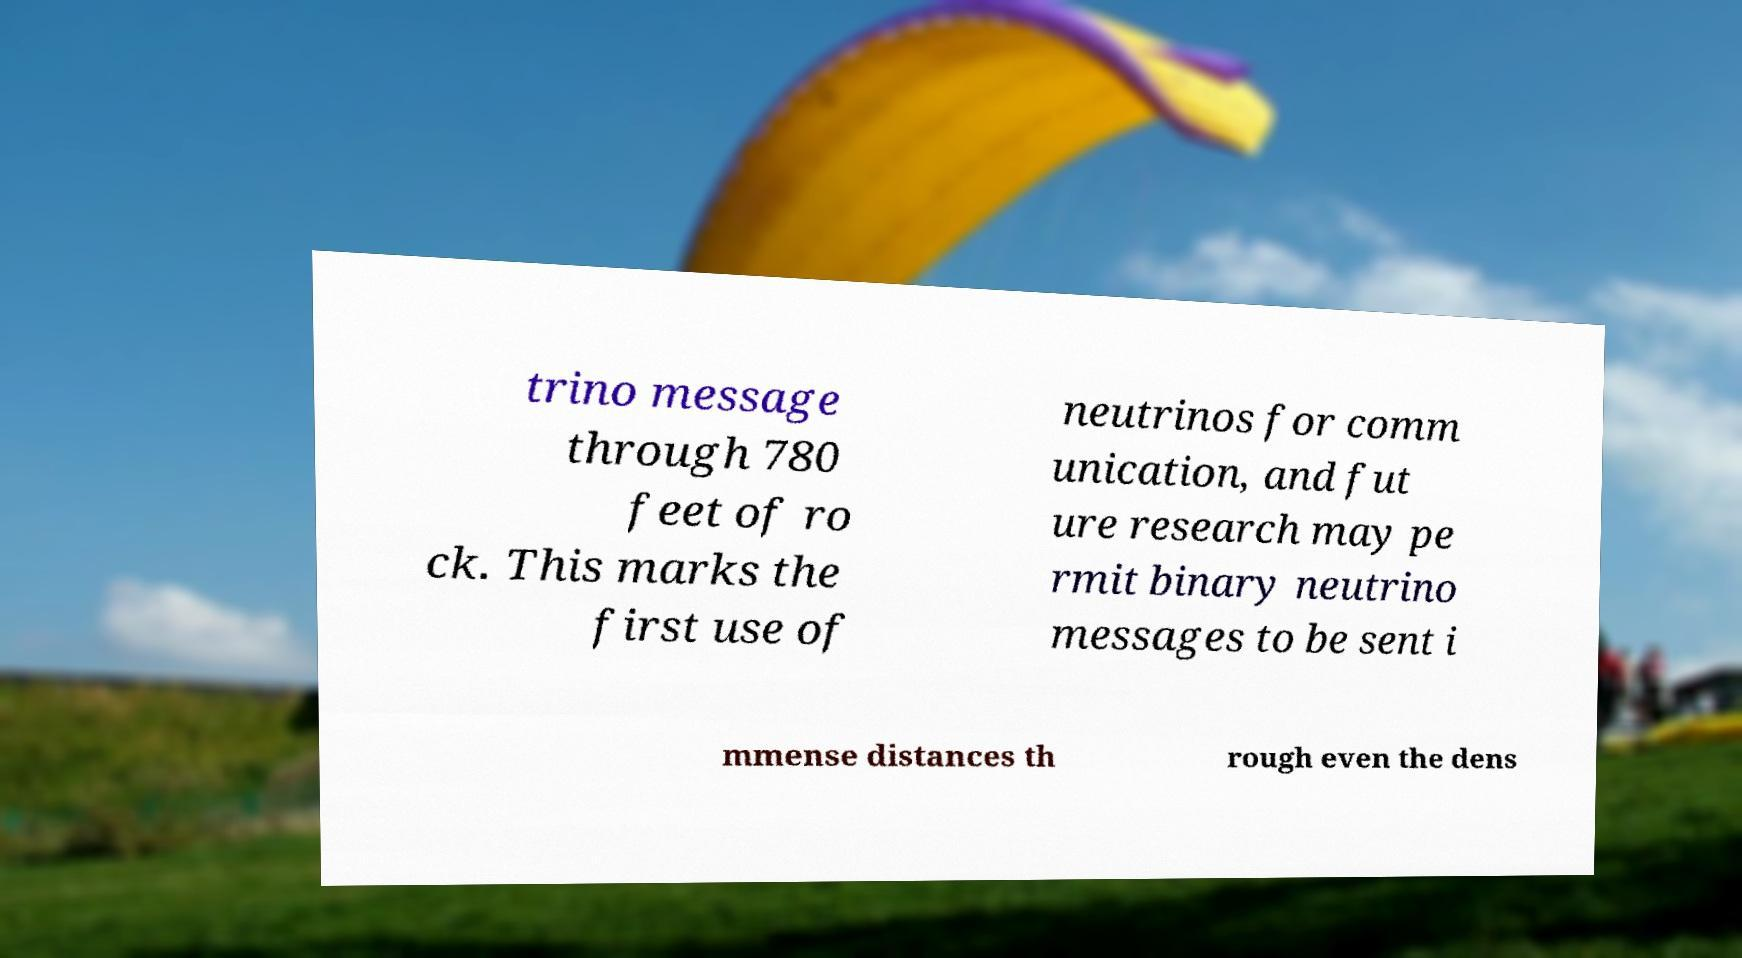For documentation purposes, I need the text within this image transcribed. Could you provide that? trino message through 780 feet of ro ck. This marks the first use of neutrinos for comm unication, and fut ure research may pe rmit binary neutrino messages to be sent i mmense distances th rough even the dens 